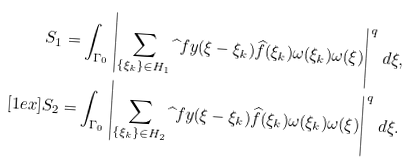Convert formula to latex. <formula><loc_0><loc_0><loc_500><loc_500>S _ { 1 } & = \int _ { \Gamma _ { 0 } } \left | \sum _ { \{ \xi _ { k } \} \in H _ { 1 } } \widehat { \ } f y ( \xi - \xi _ { k } ) \widehat { f } ( \xi _ { k } ) \omega ( \xi _ { k } ) \omega ( \xi ) \right | ^ { q } \, d \xi , \\ [ 1 e x ] S _ { 2 } & = \int _ { \Gamma _ { 0 } } \left | \sum _ { \{ \xi _ { k } \} \in H _ { 2 } } \widehat { \ } f y ( \xi - \xi _ { k } ) \widehat { f } ( \xi _ { k } ) \omega ( \xi _ { k } ) \omega ( \xi ) \right | ^ { q } \, d \xi .</formula> 